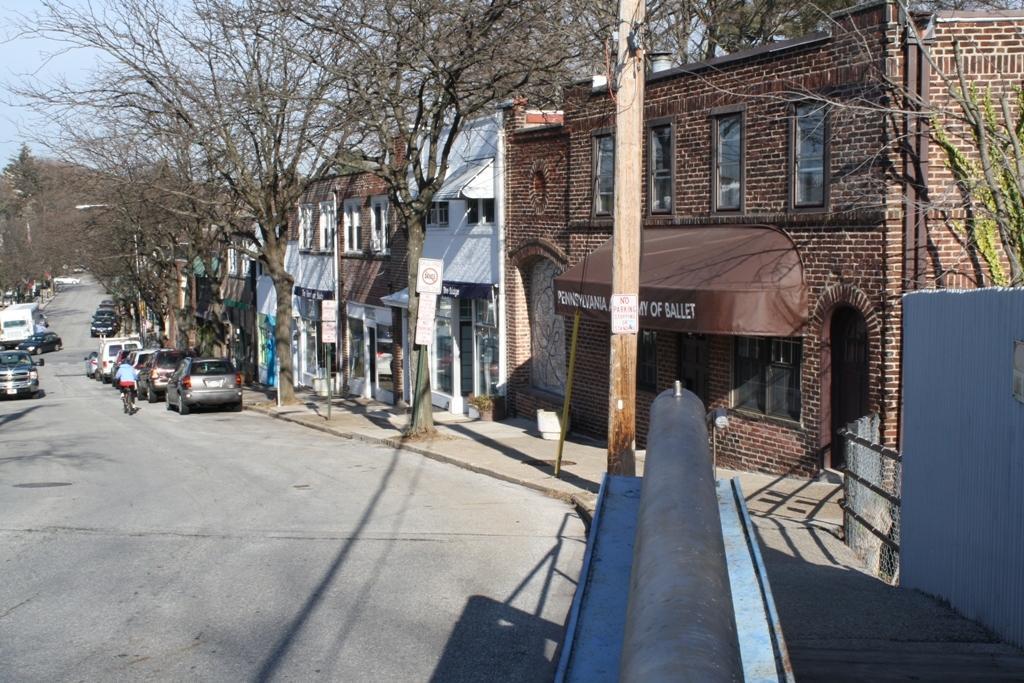Please provide a concise description of this image. In the image in the center, we can see a few vehicles on the road. And we can see one person riding cycle on the road. In the background, we can see the sky, trees, buildings, windows, banners, poles, sign boards, fences etc. 